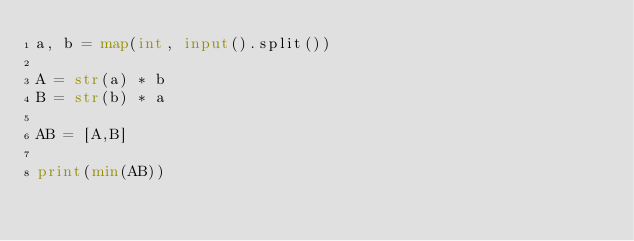<code> <loc_0><loc_0><loc_500><loc_500><_Python_>a, b = map(int, input().split())

A = str(a) * b
B = str(b) * a

AB = [A,B]

print(min(AB))</code> 